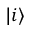Convert formula to latex. <formula><loc_0><loc_0><loc_500><loc_500>| i \rangle</formula> 